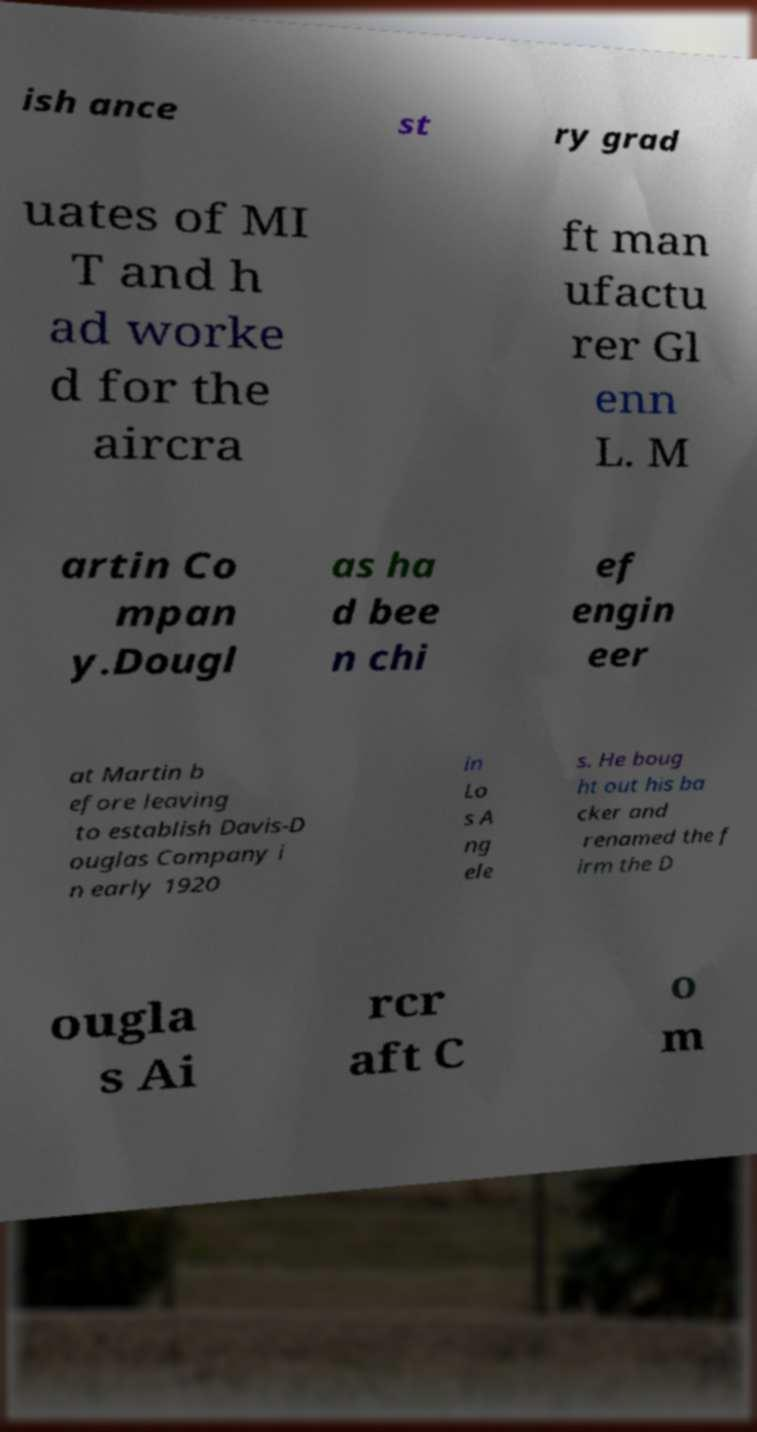Could you extract and type out the text from this image? ish ance st ry grad uates of MI T and h ad worke d for the aircra ft man ufactu rer Gl enn L. M artin Co mpan y.Dougl as ha d bee n chi ef engin eer at Martin b efore leaving to establish Davis-D ouglas Company i n early 1920 in Lo s A ng ele s. He boug ht out his ba cker and renamed the f irm the D ougla s Ai rcr aft C o m 